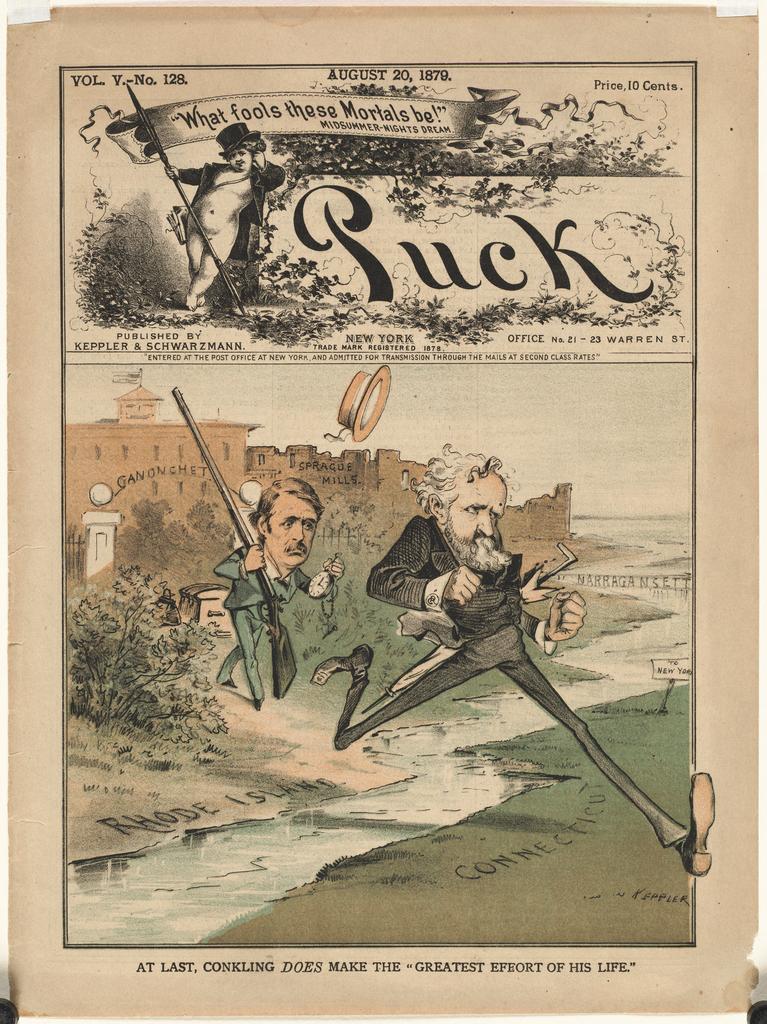What is the title of the ad?
Offer a terse response. Puck. 